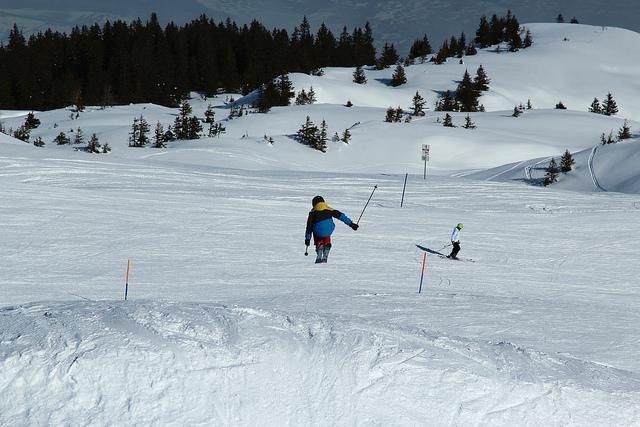How many snowboarders in this picture?
Give a very brief answer. 2. 